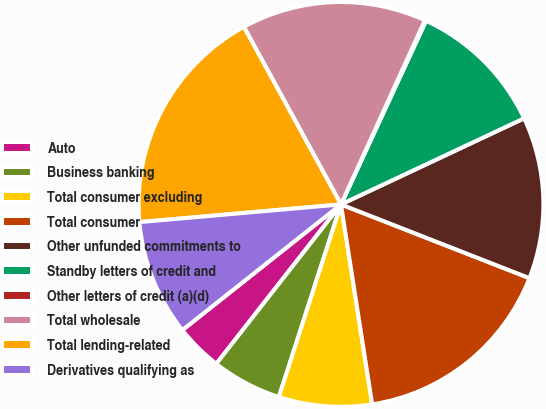<chart> <loc_0><loc_0><loc_500><loc_500><pie_chart><fcel>Auto<fcel>Business banking<fcel>Total consumer excluding<fcel>Total consumer<fcel>Other unfunded commitments to<fcel>Standby letters of credit and<fcel>Other letters of credit (a)(d)<fcel>Total wholesale<fcel>Total lending-related<fcel>Derivatives qualifying as<nl><fcel>3.77%<fcel>5.6%<fcel>7.43%<fcel>16.6%<fcel>12.93%<fcel>11.1%<fcel>0.1%<fcel>14.77%<fcel>18.43%<fcel>9.27%<nl></chart> 